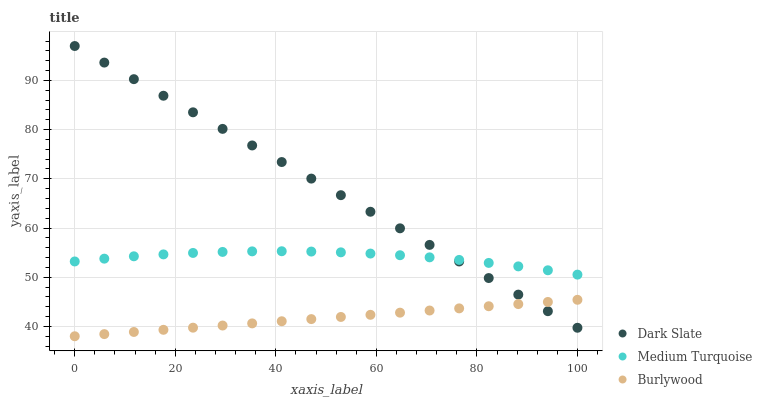Does Burlywood have the minimum area under the curve?
Answer yes or no. Yes. Does Dark Slate have the maximum area under the curve?
Answer yes or no. Yes. Does Medium Turquoise have the minimum area under the curve?
Answer yes or no. No. Does Medium Turquoise have the maximum area under the curve?
Answer yes or no. No. Is Dark Slate the smoothest?
Answer yes or no. Yes. Is Medium Turquoise the roughest?
Answer yes or no. Yes. Is Medium Turquoise the smoothest?
Answer yes or no. No. Is Dark Slate the roughest?
Answer yes or no. No. Does Burlywood have the lowest value?
Answer yes or no. Yes. Does Dark Slate have the lowest value?
Answer yes or no. No. Does Dark Slate have the highest value?
Answer yes or no. Yes. Does Medium Turquoise have the highest value?
Answer yes or no. No. Is Burlywood less than Medium Turquoise?
Answer yes or no. Yes. Is Medium Turquoise greater than Burlywood?
Answer yes or no. Yes. Does Dark Slate intersect Burlywood?
Answer yes or no. Yes. Is Dark Slate less than Burlywood?
Answer yes or no. No. Is Dark Slate greater than Burlywood?
Answer yes or no. No. Does Burlywood intersect Medium Turquoise?
Answer yes or no. No. 